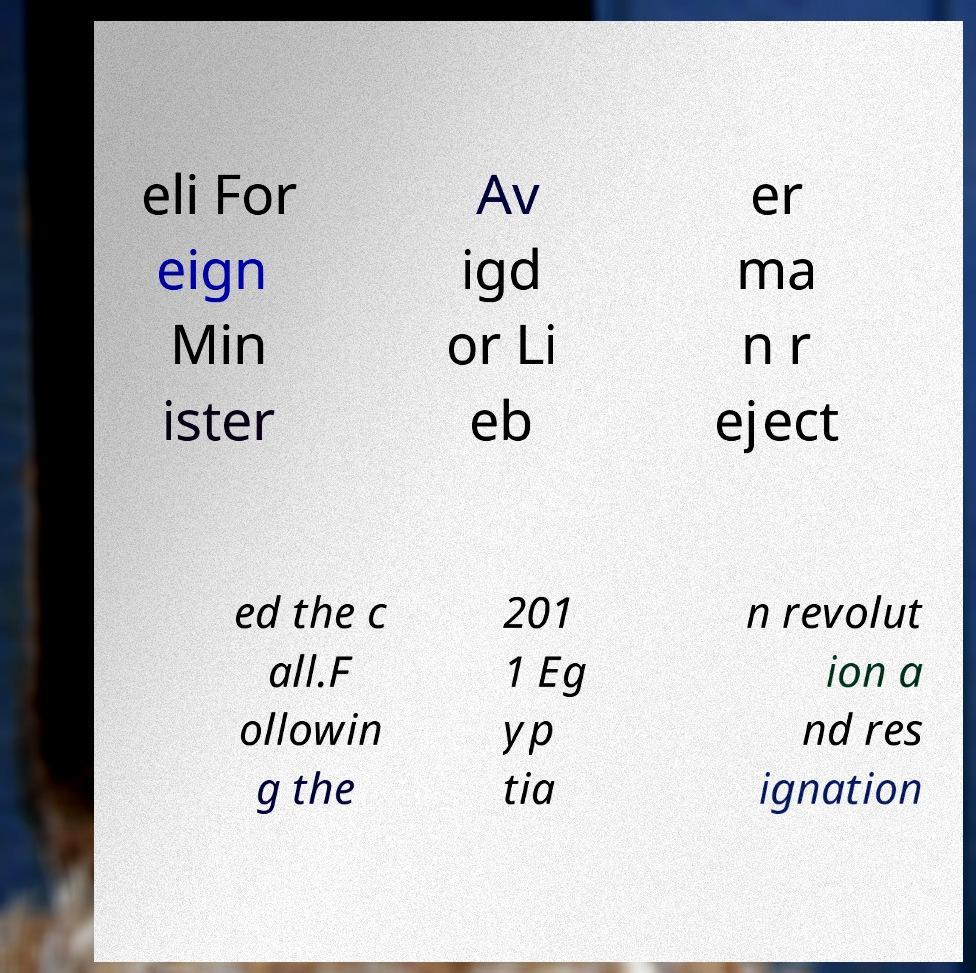What messages or text are displayed in this image? I need them in a readable, typed format. eli For eign Min ister Av igd or Li eb er ma n r eject ed the c all.F ollowin g the 201 1 Eg yp tia n revolut ion a nd res ignation 